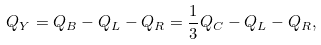Convert formula to latex. <formula><loc_0><loc_0><loc_500><loc_500>Q _ { Y } = Q _ { B } - Q _ { L } - Q _ { R } = \frac { 1 } { 3 } Q _ { C } - Q _ { L } - Q _ { R } ,</formula> 